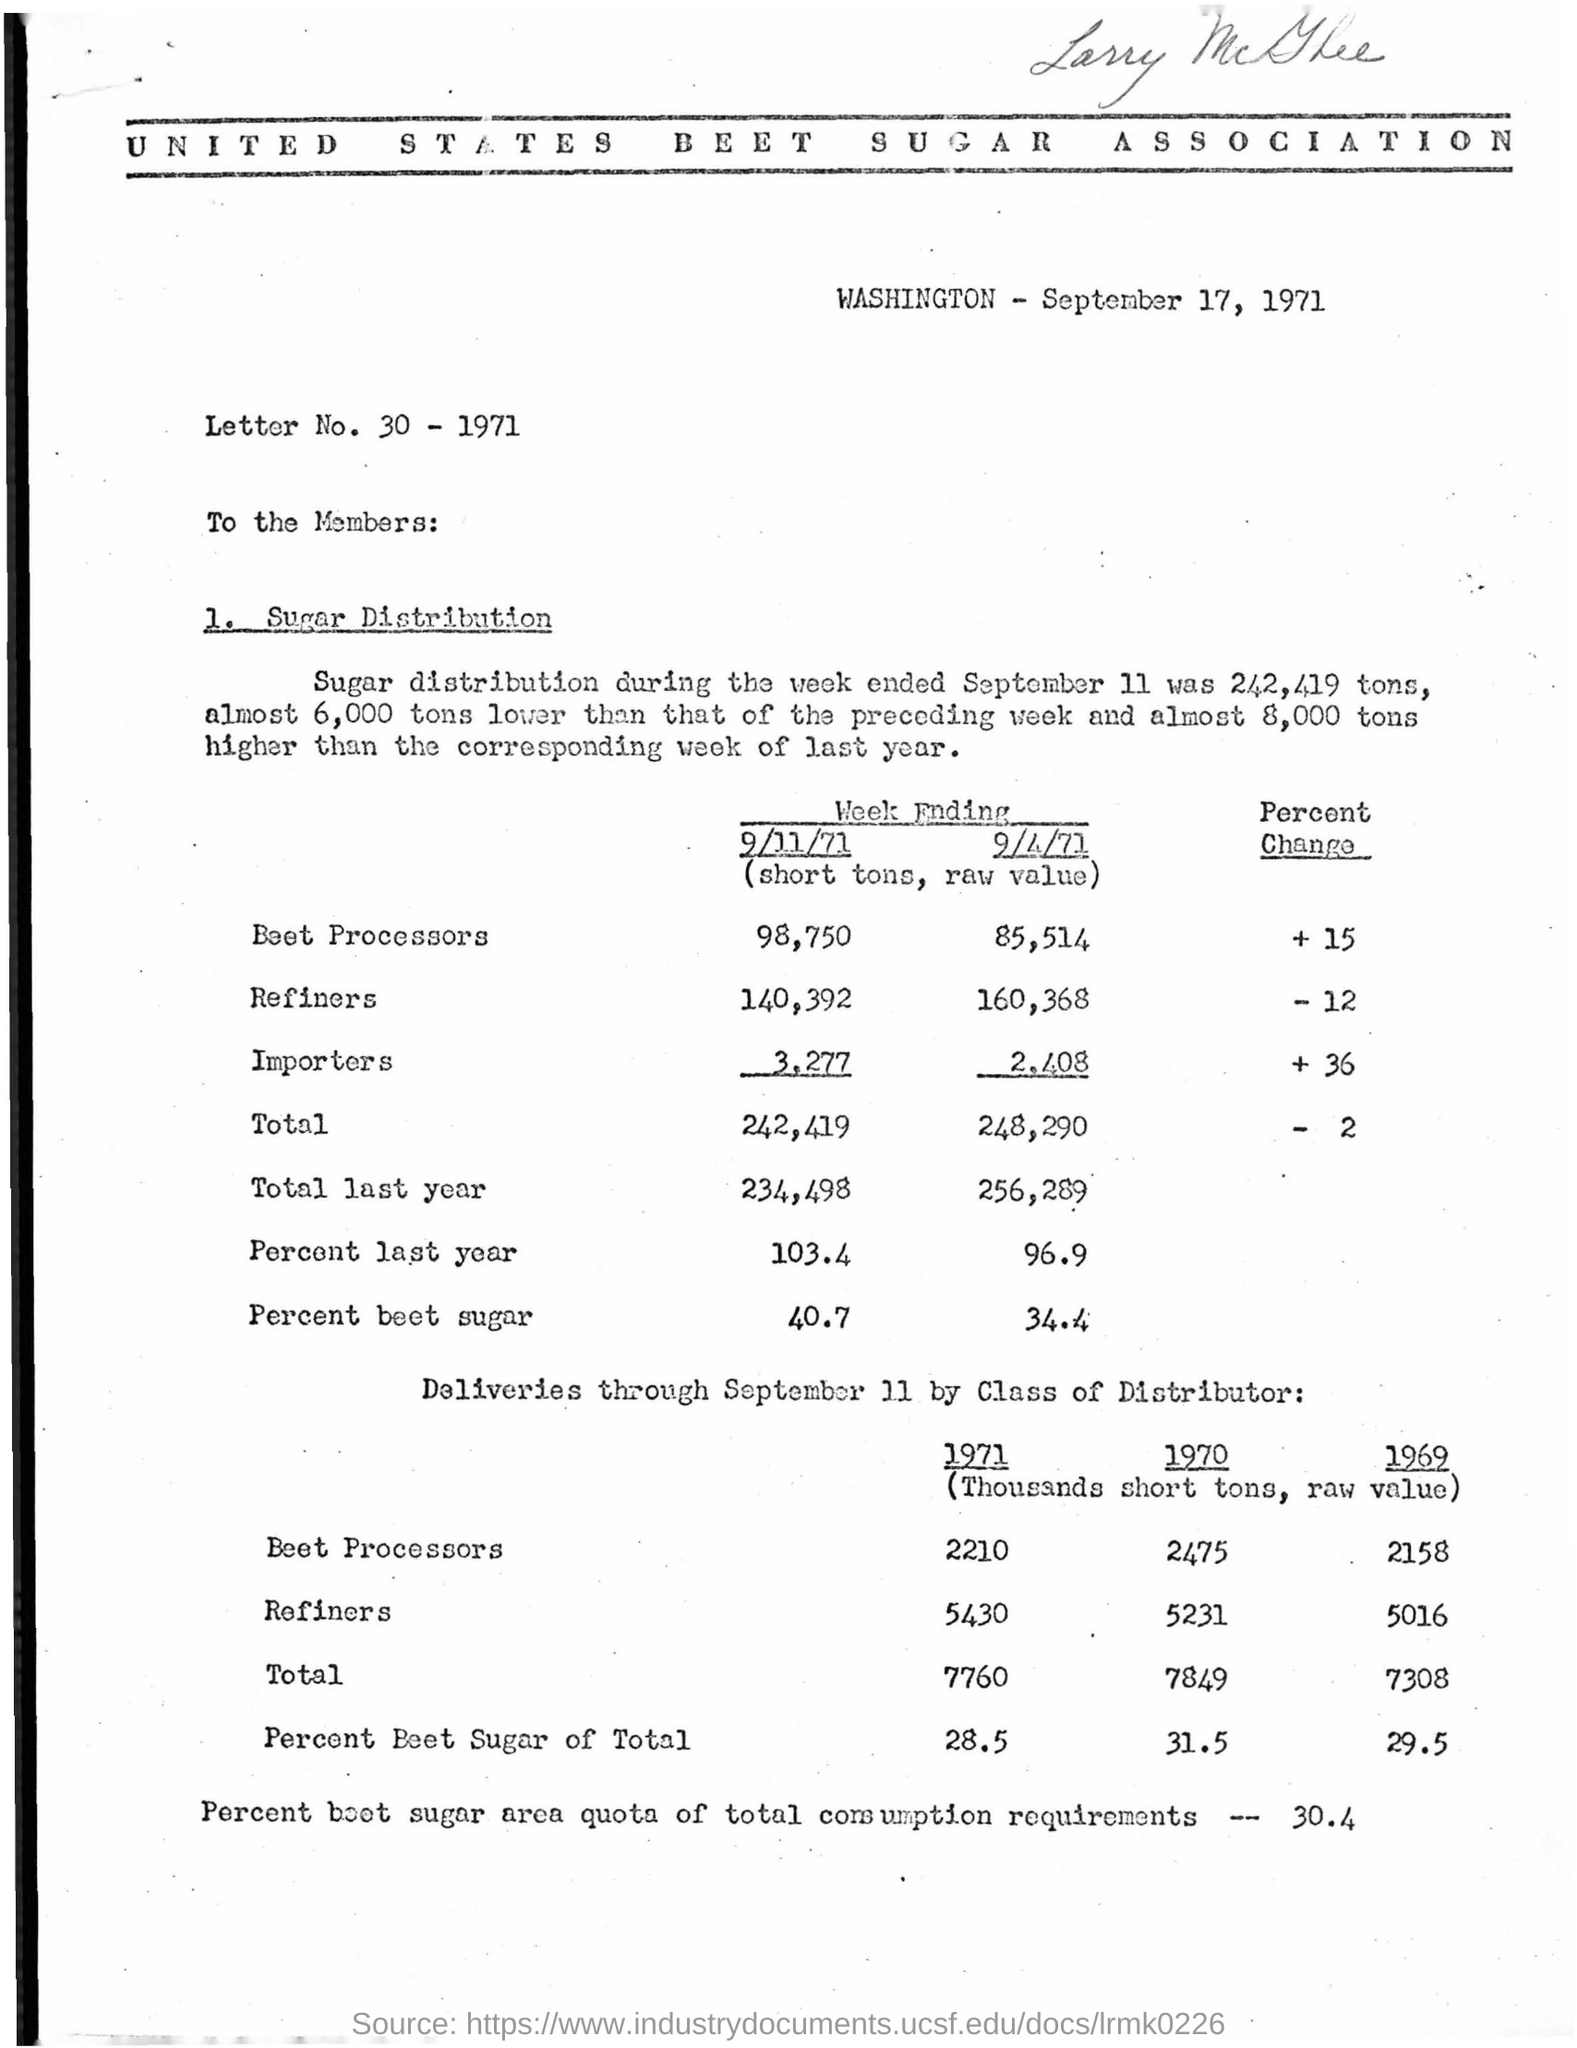What changes have occurred in the distribution from the previous year? The document indicates that the total distribution of beet sugar was almost 6,000 tons less than the same week of the preceding year and 8,000 tons higher than the corresponding week of the last year. Beet processors saw an increase of 15 percent, whereas refiners saw a decrease of 12 percent, and importers had an increase of 36 percent in distribution compared to the same period. Are there any details regarding the quotas mentioned? Yes, the document states that the percentage of beet sugar area quota of total consumption requirements was 30.4 percent. 